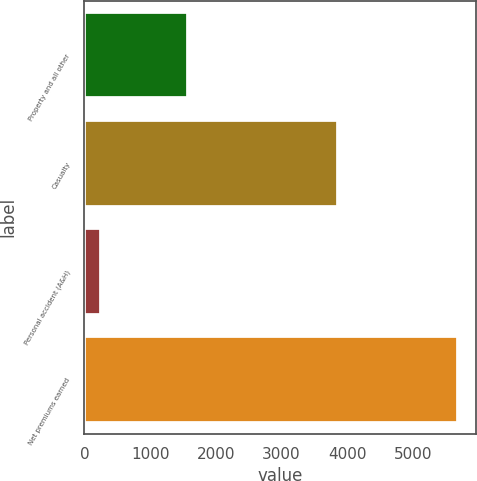Convert chart to OTSL. <chart><loc_0><loc_0><loc_500><loc_500><bar_chart><fcel>Property and all other<fcel>Casualty<fcel>Personal accident (A&H)<fcel>Net premiums earned<nl><fcel>1576<fcel>3857<fcel>246<fcel>5679<nl></chart> 